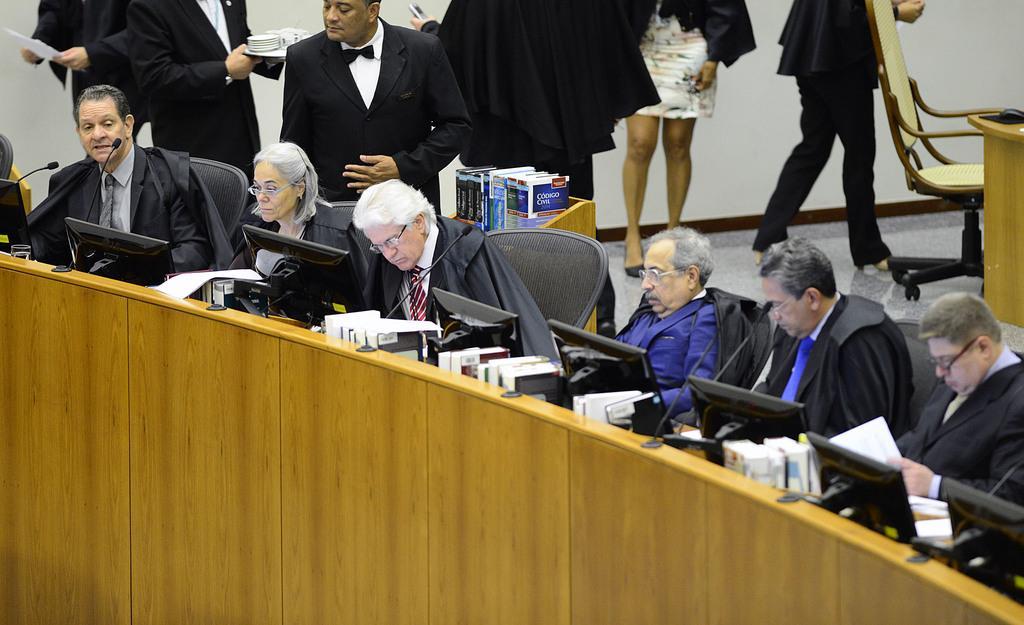Could you give a brief overview of what you see in this image? In this image there is a desk, on that desk there are computers and mike's, behind the desk there are people sitting on chairs, in the background there are people standing and there is a chair and a wall. 